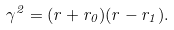Convert formula to latex. <formula><loc_0><loc_0><loc_500><loc_500>\gamma ^ { 2 } = ( r + r _ { 0 } ) ( r - r _ { 1 } ) .</formula> 